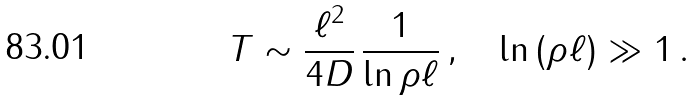<formula> <loc_0><loc_0><loc_500><loc_500>T \sim \frac { \ell ^ { 2 } } { 4 D } \, \frac { 1 } { \ln \rho \ell } \, , \quad \ln \, ( \rho \ell ) \gg 1 \, .</formula> 